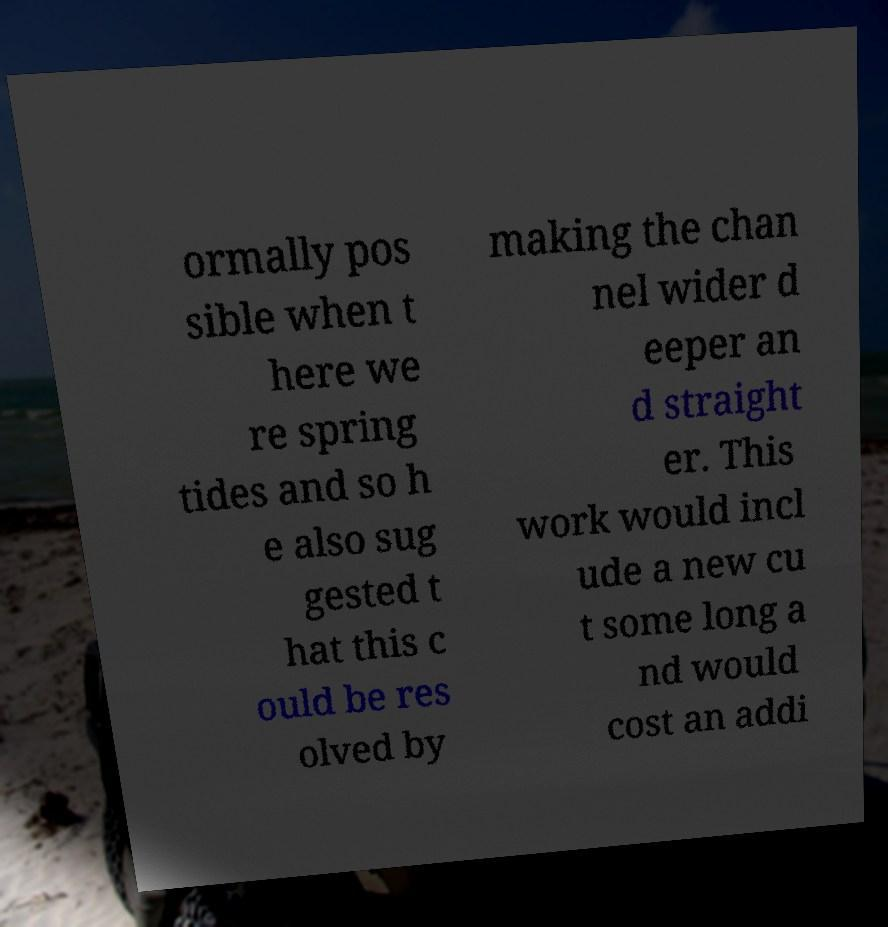There's text embedded in this image that I need extracted. Can you transcribe it verbatim? ormally pos sible when t here we re spring tides and so h e also sug gested t hat this c ould be res olved by making the chan nel wider d eeper an d straight er. This work would incl ude a new cu t some long a nd would cost an addi 